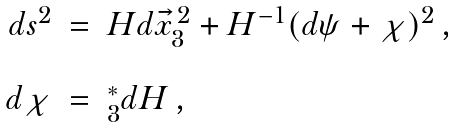<formula> <loc_0><loc_0><loc_500><loc_500>\begin{array} { r c l } d s ^ { 2 } & = & H d \vec { x } _ { 3 } ^ { \, 2 } + H ^ { - 1 } ( d \psi + \chi ) ^ { 2 } \, , \\ & & \\ d \chi & = & ^ { * } _ { 3 } d H \, , \\ \end{array}</formula> 